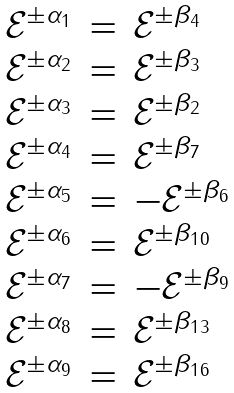Convert formula to latex. <formula><loc_0><loc_0><loc_500><loc_500>\begin{array} { l l l } \mathcal { E } ^ { \pm \alpha _ { 1 } } & = & \mathcal { E } ^ { \pm \beta _ { 4 } } \\ \mathcal { E } ^ { \pm \alpha _ { 2 } } & = & \mathcal { E } ^ { \pm \beta _ { 3 } } \\ \mathcal { E } ^ { \pm \alpha _ { 3 } } & = & \mathcal { E } ^ { \pm \beta _ { 2 } } \\ \mathcal { E } ^ { \pm \alpha _ { 4 } } & = & \mathcal { E } ^ { \pm \beta _ { 7 } } \\ \mathcal { E } ^ { \pm \alpha _ { 5 } } & = & - \mathcal { E } ^ { \pm \beta _ { 6 } } \\ \mathcal { E } ^ { \pm \alpha _ { 6 } } & = & \mathcal { E } ^ { \pm \beta _ { 1 0 } } \\ \mathcal { E } ^ { \pm \alpha _ { 7 } } & = & - \mathcal { E } ^ { \pm \beta _ { 9 } } \\ \mathcal { E } ^ { \pm \alpha _ { 8 } } & = & \mathcal { E } ^ { \pm \beta _ { 1 3 } } \\ \mathcal { E } ^ { \pm \alpha _ { 9 } } & = & \mathcal { E } ^ { \pm \beta _ { 1 6 } } \end{array}</formula> 